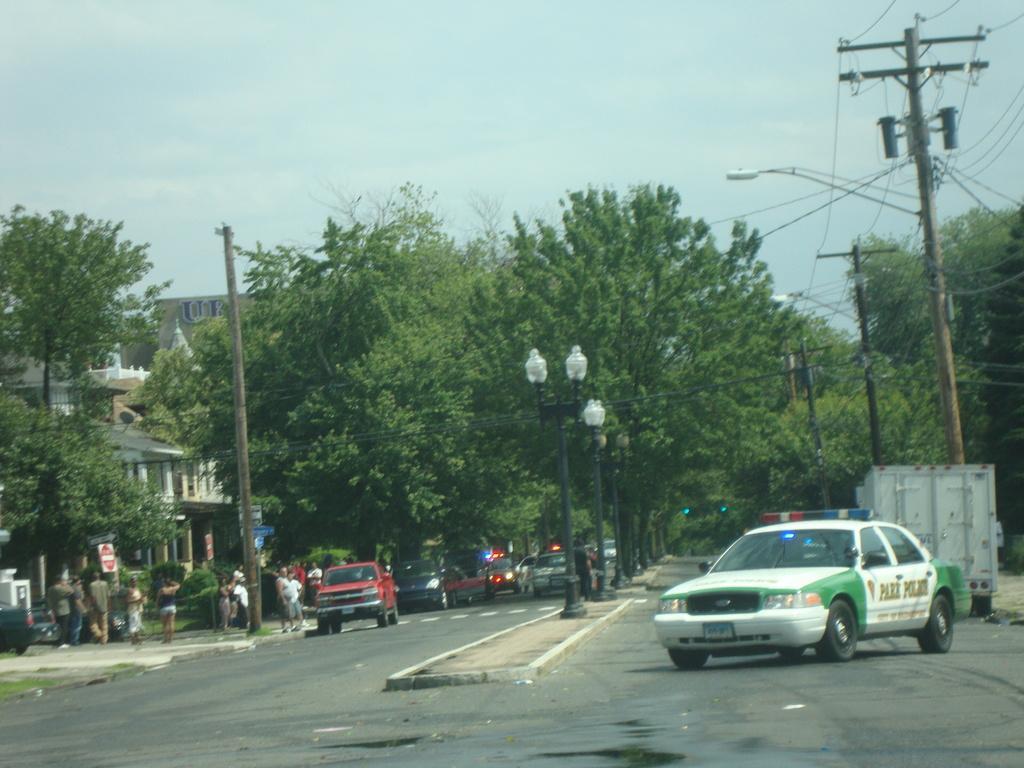Please provide a concise description of this image. In this picture we can see cars on the road, poles, trees, wires, signboards, buildings and some people on a footpath and in the background we can see the sky. 